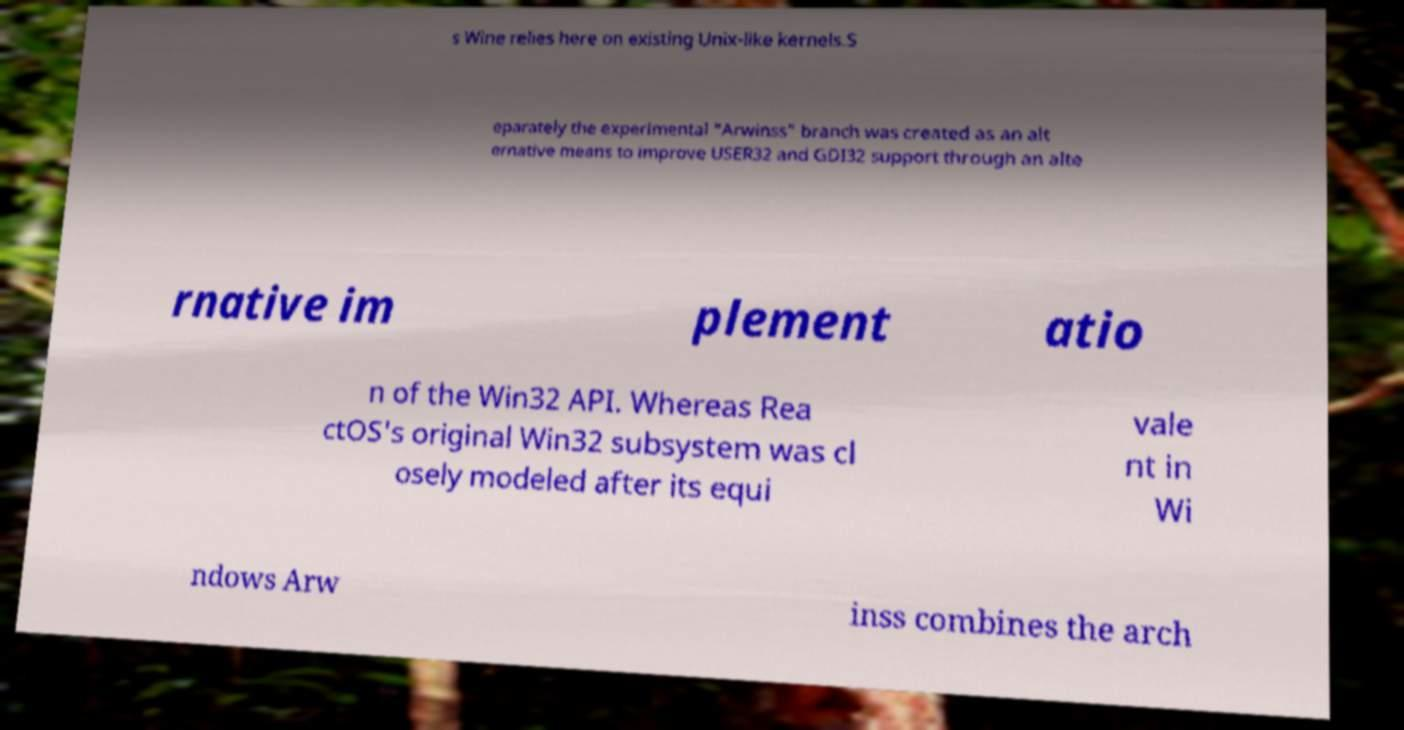Could you extract and type out the text from this image? s Wine relies here on existing Unix-like kernels.S eparately the experimental "Arwinss" branch was created as an alt ernative means to improve USER32 and GDI32 support through an alte rnative im plement atio n of the Win32 API. Whereas Rea ctOS's original Win32 subsystem was cl osely modeled after its equi vale nt in Wi ndows Arw inss combines the arch 